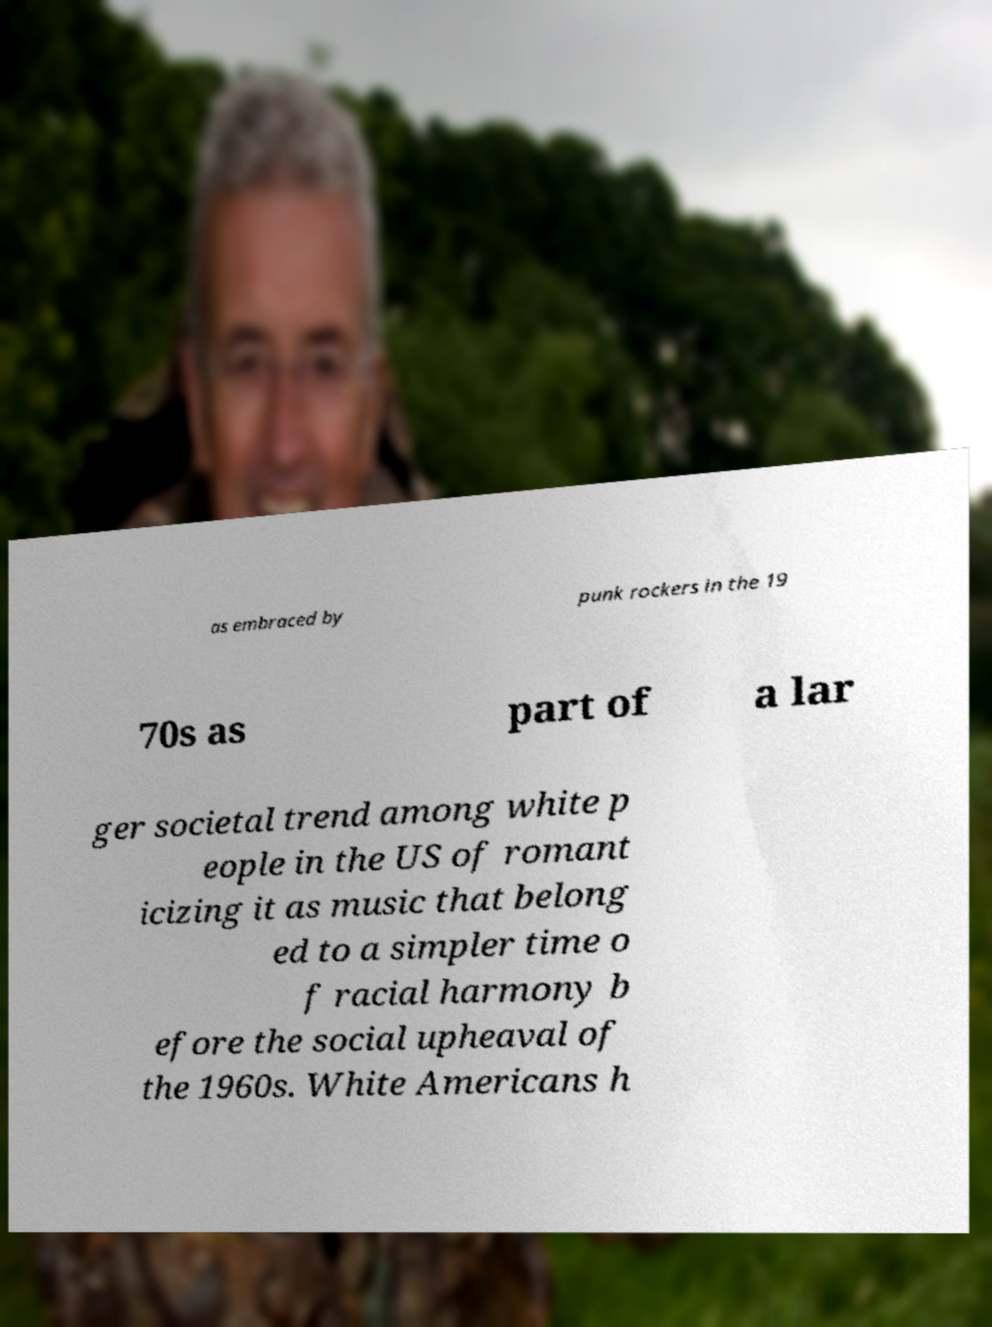Can you read and provide the text displayed in the image?This photo seems to have some interesting text. Can you extract and type it out for me? as embraced by punk rockers in the 19 70s as part of a lar ger societal trend among white p eople in the US of romant icizing it as music that belong ed to a simpler time o f racial harmony b efore the social upheaval of the 1960s. White Americans h 